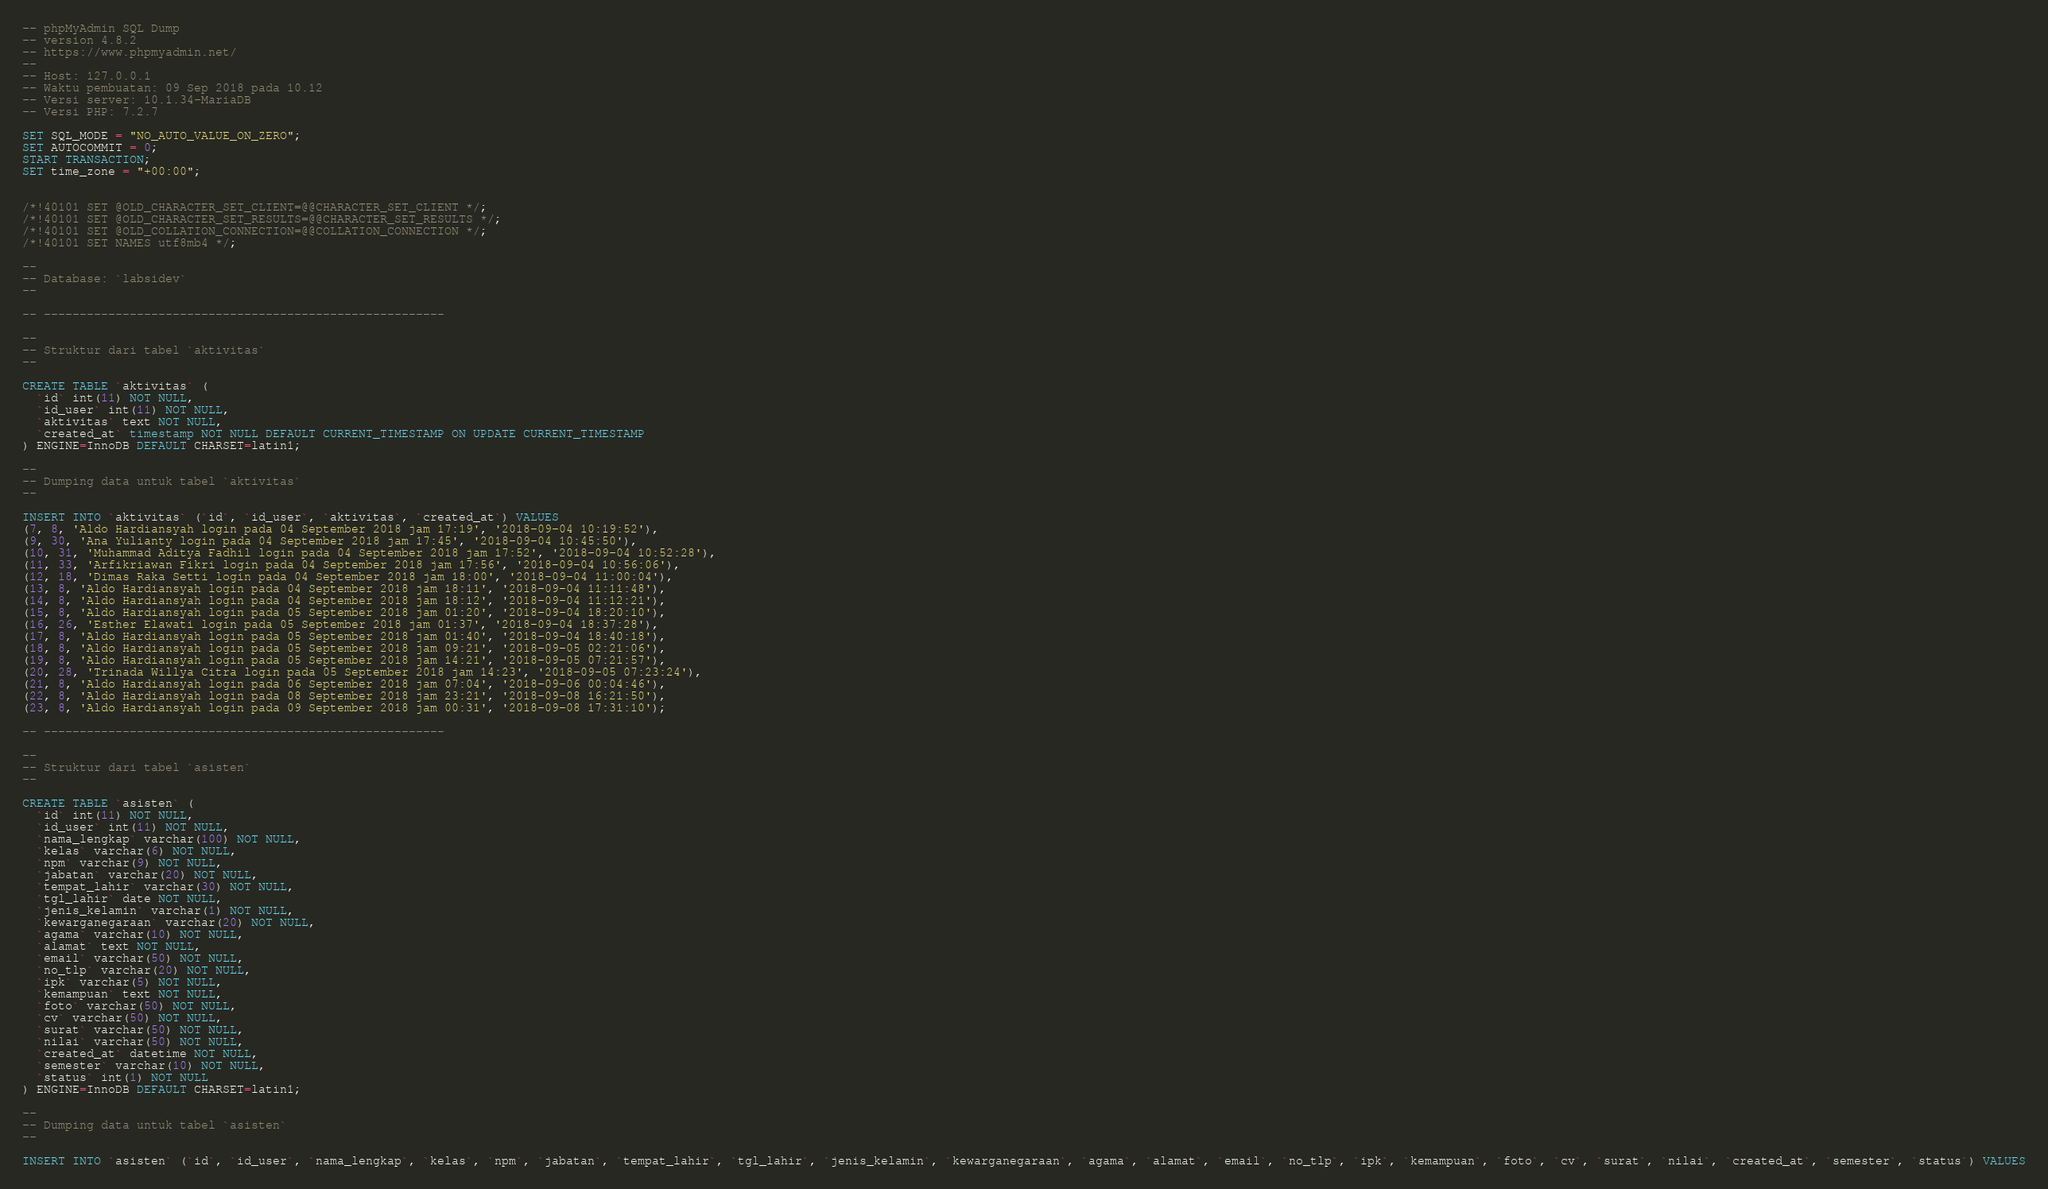Convert code to text. <code><loc_0><loc_0><loc_500><loc_500><_SQL_>-- phpMyAdmin SQL Dump
-- version 4.8.2
-- https://www.phpmyadmin.net/
--
-- Host: 127.0.0.1
-- Waktu pembuatan: 09 Sep 2018 pada 10.12
-- Versi server: 10.1.34-MariaDB
-- Versi PHP: 7.2.7

SET SQL_MODE = "NO_AUTO_VALUE_ON_ZERO";
SET AUTOCOMMIT = 0;
START TRANSACTION;
SET time_zone = "+00:00";


/*!40101 SET @OLD_CHARACTER_SET_CLIENT=@@CHARACTER_SET_CLIENT */;
/*!40101 SET @OLD_CHARACTER_SET_RESULTS=@@CHARACTER_SET_RESULTS */;
/*!40101 SET @OLD_COLLATION_CONNECTION=@@COLLATION_CONNECTION */;
/*!40101 SET NAMES utf8mb4 */;

--
-- Database: `labsidev`
--

-- --------------------------------------------------------

--
-- Struktur dari tabel `aktivitas`
--

CREATE TABLE `aktivitas` (
  `id` int(11) NOT NULL,
  `id_user` int(11) NOT NULL,
  `aktivitas` text NOT NULL,
  `created_at` timestamp NOT NULL DEFAULT CURRENT_TIMESTAMP ON UPDATE CURRENT_TIMESTAMP
) ENGINE=InnoDB DEFAULT CHARSET=latin1;

--
-- Dumping data untuk tabel `aktivitas`
--

INSERT INTO `aktivitas` (`id`, `id_user`, `aktivitas`, `created_at`) VALUES
(7, 8, 'Aldo Hardiansyah login pada 04 September 2018 jam 17:19', '2018-09-04 10:19:52'),
(9, 30, 'Ana Yulianty login pada 04 September 2018 jam 17:45', '2018-09-04 10:45:50'),
(10, 31, 'Muhammad Aditya Fadhil login pada 04 September 2018 jam 17:52', '2018-09-04 10:52:28'),
(11, 33, 'Arfikriawan Fikri login pada 04 September 2018 jam 17:56', '2018-09-04 10:56:06'),
(12, 18, 'Dimas Raka Setti login pada 04 September 2018 jam 18:00', '2018-09-04 11:00:04'),
(13, 8, 'Aldo Hardiansyah login pada 04 September 2018 jam 18:11', '2018-09-04 11:11:48'),
(14, 8, 'Aldo Hardiansyah login pada 04 September 2018 jam 18:12', '2018-09-04 11:12:21'),
(15, 8, 'Aldo Hardiansyah login pada 05 September 2018 jam 01:20', '2018-09-04 18:20:10'),
(16, 26, 'Esther Elawati login pada 05 September 2018 jam 01:37', '2018-09-04 18:37:28'),
(17, 8, 'Aldo Hardiansyah login pada 05 September 2018 jam 01:40', '2018-09-04 18:40:18'),
(18, 8, 'Aldo Hardiansyah login pada 05 September 2018 jam 09:21', '2018-09-05 02:21:06'),
(19, 8, 'Aldo Hardiansyah login pada 05 September 2018 jam 14:21', '2018-09-05 07:21:57'),
(20, 28, 'Trinada Willya Citra login pada 05 September 2018 jam 14:23', '2018-09-05 07:23:24'),
(21, 8, 'Aldo Hardiansyah login pada 06 September 2018 jam 07:04', '2018-09-06 00:04:46'),
(22, 8, 'Aldo Hardiansyah login pada 08 September 2018 jam 23:21', '2018-09-08 16:21:50'),
(23, 8, 'Aldo Hardiansyah login pada 09 September 2018 jam 00:31', '2018-09-08 17:31:10');

-- --------------------------------------------------------

--
-- Struktur dari tabel `asisten`
--

CREATE TABLE `asisten` (
  `id` int(11) NOT NULL,
  `id_user` int(11) NOT NULL,
  `nama_lengkap` varchar(100) NOT NULL,
  `kelas` varchar(6) NOT NULL,
  `npm` varchar(9) NOT NULL,
  `jabatan` varchar(20) NOT NULL,
  `tempat_lahir` varchar(30) NOT NULL,
  `tgl_lahir` date NOT NULL,
  `jenis_kelamin` varchar(1) NOT NULL,
  `kewarganegaraan` varchar(20) NOT NULL,
  `agama` varchar(10) NOT NULL,
  `alamat` text NOT NULL,
  `email` varchar(50) NOT NULL,
  `no_tlp` varchar(20) NOT NULL,
  `ipk` varchar(5) NOT NULL,
  `kemampuan` text NOT NULL,
  `foto` varchar(50) NOT NULL,
  `cv` varchar(50) NOT NULL,
  `surat` varchar(50) NOT NULL,
  `nilai` varchar(50) NOT NULL,
  `created_at` datetime NOT NULL,
  `semester` varchar(10) NOT NULL,
  `status` int(1) NOT NULL
) ENGINE=InnoDB DEFAULT CHARSET=latin1;

--
-- Dumping data untuk tabel `asisten`
--

INSERT INTO `asisten` (`id`, `id_user`, `nama_lengkap`, `kelas`, `npm`, `jabatan`, `tempat_lahir`, `tgl_lahir`, `jenis_kelamin`, `kewarganegaraan`, `agama`, `alamat`, `email`, `no_tlp`, `ipk`, `kemampuan`, `foto`, `cv`, `surat`, `nilai`, `created_at`, `semester`, `status`) VALUES</code> 